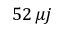Convert formula to latex. <formula><loc_0><loc_0><loc_500><loc_500>5 2 \, \mu j</formula> 